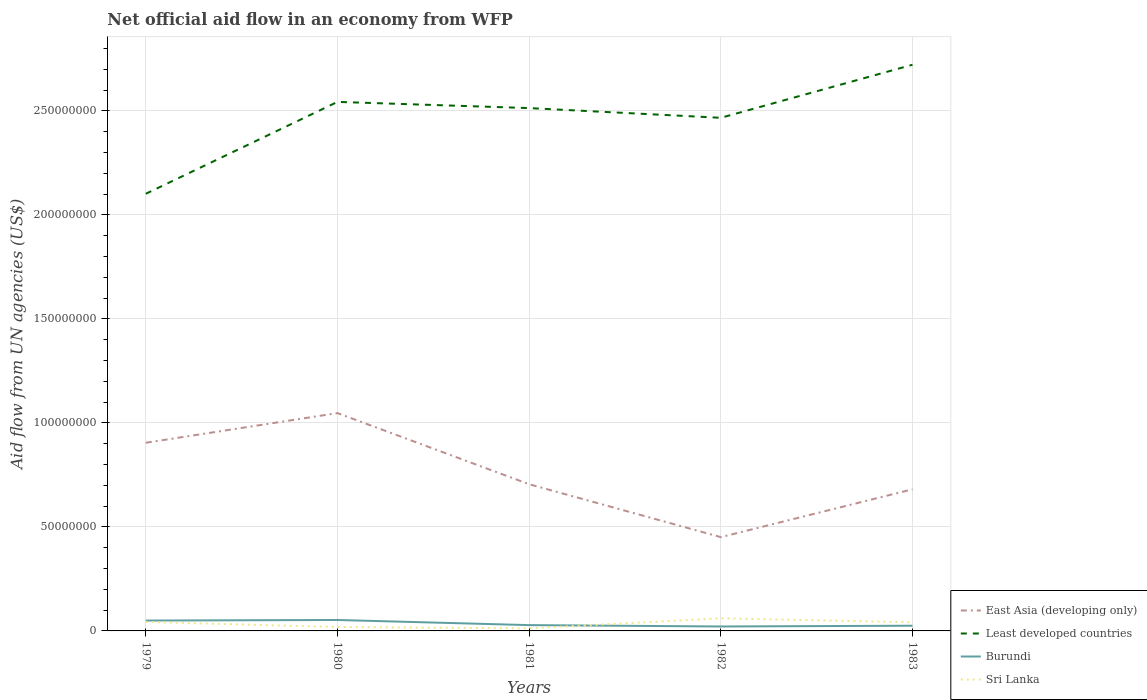How many different coloured lines are there?
Make the answer very short. 4. Is the number of lines equal to the number of legend labels?
Offer a very short reply. Yes. Across all years, what is the maximum net official aid flow in East Asia (developing only)?
Ensure brevity in your answer.  4.51e+07. In which year was the net official aid flow in Burundi maximum?
Give a very brief answer. 1982. What is the total net official aid flow in Sri Lanka in the graph?
Provide a short and direct response. -4.19e+06. What is the difference between the highest and the second highest net official aid flow in Burundi?
Your answer should be compact. 3.13e+06. Is the net official aid flow in Sri Lanka strictly greater than the net official aid flow in East Asia (developing only) over the years?
Offer a terse response. Yes. What is the difference between two consecutive major ticks on the Y-axis?
Your answer should be very brief. 5.00e+07. Are the values on the major ticks of Y-axis written in scientific E-notation?
Provide a short and direct response. No. Does the graph contain any zero values?
Make the answer very short. No. Does the graph contain grids?
Make the answer very short. Yes. How many legend labels are there?
Ensure brevity in your answer.  4. How are the legend labels stacked?
Keep it short and to the point. Vertical. What is the title of the graph?
Ensure brevity in your answer.  Net official aid flow in an economy from WFP. Does "Sub-Saharan Africa (developing only)" appear as one of the legend labels in the graph?
Your answer should be compact. No. What is the label or title of the X-axis?
Your answer should be very brief. Years. What is the label or title of the Y-axis?
Offer a very short reply. Aid flow from UN agencies (US$). What is the Aid flow from UN agencies (US$) of East Asia (developing only) in 1979?
Offer a very short reply. 9.04e+07. What is the Aid flow from UN agencies (US$) in Least developed countries in 1979?
Offer a very short reply. 2.10e+08. What is the Aid flow from UN agencies (US$) in Burundi in 1979?
Your answer should be compact. 4.99e+06. What is the Aid flow from UN agencies (US$) in Sri Lanka in 1979?
Ensure brevity in your answer.  4.31e+06. What is the Aid flow from UN agencies (US$) of East Asia (developing only) in 1980?
Make the answer very short. 1.05e+08. What is the Aid flow from UN agencies (US$) of Least developed countries in 1980?
Make the answer very short. 2.54e+08. What is the Aid flow from UN agencies (US$) of Burundi in 1980?
Your answer should be very brief. 5.26e+06. What is the Aid flow from UN agencies (US$) in Sri Lanka in 1980?
Provide a succinct answer. 1.89e+06. What is the Aid flow from UN agencies (US$) of East Asia (developing only) in 1981?
Offer a terse response. 7.05e+07. What is the Aid flow from UN agencies (US$) of Least developed countries in 1981?
Your response must be concise. 2.51e+08. What is the Aid flow from UN agencies (US$) of Burundi in 1981?
Your answer should be very brief. 2.79e+06. What is the Aid flow from UN agencies (US$) of Sri Lanka in 1981?
Give a very brief answer. 1.23e+06. What is the Aid flow from UN agencies (US$) of East Asia (developing only) in 1982?
Ensure brevity in your answer.  4.51e+07. What is the Aid flow from UN agencies (US$) in Least developed countries in 1982?
Give a very brief answer. 2.47e+08. What is the Aid flow from UN agencies (US$) in Burundi in 1982?
Provide a succinct answer. 2.13e+06. What is the Aid flow from UN agencies (US$) of Sri Lanka in 1982?
Offer a terse response. 6.08e+06. What is the Aid flow from UN agencies (US$) in East Asia (developing only) in 1983?
Your response must be concise. 6.81e+07. What is the Aid flow from UN agencies (US$) of Least developed countries in 1983?
Offer a very short reply. 2.72e+08. What is the Aid flow from UN agencies (US$) in Burundi in 1983?
Keep it short and to the point. 2.50e+06. What is the Aid flow from UN agencies (US$) of Sri Lanka in 1983?
Keep it short and to the point. 4.14e+06. Across all years, what is the maximum Aid flow from UN agencies (US$) of East Asia (developing only)?
Ensure brevity in your answer.  1.05e+08. Across all years, what is the maximum Aid flow from UN agencies (US$) in Least developed countries?
Ensure brevity in your answer.  2.72e+08. Across all years, what is the maximum Aid flow from UN agencies (US$) of Burundi?
Offer a terse response. 5.26e+06. Across all years, what is the maximum Aid flow from UN agencies (US$) in Sri Lanka?
Offer a terse response. 6.08e+06. Across all years, what is the minimum Aid flow from UN agencies (US$) of East Asia (developing only)?
Ensure brevity in your answer.  4.51e+07. Across all years, what is the minimum Aid flow from UN agencies (US$) of Least developed countries?
Your response must be concise. 2.10e+08. Across all years, what is the minimum Aid flow from UN agencies (US$) in Burundi?
Give a very brief answer. 2.13e+06. Across all years, what is the minimum Aid flow from UN agencies (US$) in Sri Lanka?
Provide a short and direct response. 1.23e+06. What is the total Aid flow from UN agencies (US$) in East Asia (developing only) in the graph?
Give a very brief answer. 3.79e+08. What is the total Aid flow from UN agencies (US$) of Least developed countries in the graph?
Provide a succinct answer. 1.23e+09. What is the total Aid flow from UN agencies (US$) in Burundi in the graph?
Give a very brief answer. 1.77e+07. What is the total Aid flow from UN agencies (US$) in Sri Lanka in the graph?
Your answer should be compact. 1.76e+07. What is the difference between the Aid flow from UN agencies (US$) of East Asia (developing only) in 1979 and that in 1980?
Give a very brief answer. -1.42e+07. What is the difference between the Aid flow from UN agencies (US$) of Least developed countries in 1979 and that in 1980?
Give a very brief answer. -4.42e+07. What is the difference between the Aid flow from UN agencies (US$) of Sri Lanka in 1979 and that in 1980?
Your answer should be very brief. 2.42e+06. What is the difference between the Aid flow from UN agencies (US$) in East Asia (developing only) in 1979 and that in 1981?
Your answer should be compact. 1.99e+07. What is the difference between the Aid flow from UN agencies (US$) of Least developed countries in 1979 and that in 1981?
Give a very brief answer. -4.12e+07. What is the difference between the Aid flow from UN agencies (US$) in Burundi in 1979 and that in 1981?
Provide a succinct answer. 2.20e+06. What is the difference between the Aid flow from UN agencies (US$) in Sri Lanka in 1979 and that in 1981?
Provide a succinct answer. 3.08e+06. What is the difference between the Aid flow from UN agencies (US$) of East Asia (developing only) in 1979 and that in 1982?
Keep it short and to the point. 4.54e+07. What is the difference between the Aid flow from UN agencies (US$) of Least developed countries in 1979 and that in 1982?
Make the answer very short. -3.65e+07. What is the difference between the Aid flow from UN agencies (US$) in Burundi in 1979 and that in 1982?
Your answer should be compact. 2.86e+06. What is the difference between the Aid flow from UN agencies (US$) in Sri Lanka in 1979 and that in 1982?
Offer a terse response. -1.77e+06. What is the difference between the Aid flow from UN agencies (US$) of East Asia (developing only) in 1979 and that in 1983?
Your answer should be compact. 2.24e+07. What is the difference between the Aid flow from UN agencies (US$) in Least developed countries in 1979 and that in 1983?
Keep it short and to the point. -6.20e+07. What is the difference between the Aid flow from UN agencies (US$) in Burundi in 1979 and that in 1983?
Your answer should be very brief. 2.49e+06. What is the difference between the Aid flow from UN agencies (US$) of East Asia (developing only) in 1980 and that in 1981?
Keep it short and to the point. 3.42e+07. What is the difference between the Aid flow from UN agencies (US$) in Least developed countries in 1980 and that in 1981?
Your answer should be compact. 2.98e+06. What is the difference between the Aid flow from UN agencies (US$) in Burundi in 1980 and that in 1981?
Provide a short and direct response. 2.47e+06. What is the difference between the Aid flow from UN agencies (US$) of East Asia (developing only) in 1980 and that in 1982?
Give a very brief answer. 5.96e+07. What is the difference between the Aid flow from UN agencies (US$) of Least developed countries in 1980 and that in 1982?
Give a very brief answer. 7.65e+06. What is the difference between the Aid flow from UN agencies (US$) in Burundi in 1980 and that in 1982?
Keep it short and to the point. 3.13e+06. What is the difference between the Aid flow from UN agencies (US$) of Sri Lanka in 1980 and that in 1982?
Offer a terse response. -4.19e+06. What is the difference between the Aid flow from UN agencies (US$) in East Asia (developing only) in 1980 and that in 1983?
Your answer should be compact. 3.66e+07. What is the difference between the Aid flow from UN agencies (US$) in Least developed countries in 1980 and that in 1983?
Make the answer very short. -1.78e+07. What is the difference between the Aid flow from UN agencies (US$) in Burundi in 1980 and that in 1983?
Ensure brevity in your answer.  2.76e+06. What is the difference between the Aid flow from UN agencies (US$) of Sri Lanka in 1980 and that in 1983?
Make the answer very short. -2.25e+06. What is the difference between the Aid flow from UN agencies (US$) in East Asia (developing only) in 1981 and that in 1982?
Ensure brevity in your answer.  2.54e+07. What is the difference between the Aid flow from UN agencies (US$) of Least developed countries in 1981 and that in 1982?
Keep it short and to the point. 4.67e+06. What is the difference between the Aid flow from UN agencies (US$) of Burundi in 1981 and that in 1982?
Ensure brevity in your answer.  6.60e+05. What is the difference between the Aid flow from UN agencies (US$) of Sri Lanka in 1981 and that in 1982?
Your answer should be very brief. -4.85e+06. What is the difference between the Aid flow from UN agencies (US$) in East Asia (developing only) in 1981 and that in 1983?
Keep it short and to the point. 2.44e+06. What is the difference between the Aid flow from UN agencies (US$) of Least developed countries in 1981 and that in 1983?
Your response must be concise. -2.08e+07. What is the difference between the Aid flow from UN agencies (US$) of Sri Lanka in 1981 and that in 1983?
Provide a succinct answer. -2.91e+06. What is the difference between the Aid flow from UN agencies (US$) of East Asia (developing only) in 1982 and that in 1983?
Your answer should be compact. -2.30e+07. What is the difference between the Aid flow from UN agencies (US$) in Least developed countries in 1982 and that in 1983?
Your answer should be very brief. -2.55e+07. What is the difference between the Aid flow from UN agencies (US$) in Burundi in 1982 and that in 1983?
Your answer should be very brief. -3.70e+05. What is the difference between the Aid flow from UN agencies (US$) of Sri Lanka in 1982 and that in 1983?
Offer a terse response. 1.94e+06. What is the difference between the Aid flow from UN agencies (US$) of East Asia (developing only) in 1979 and the Aid flow from UN agencies (US$) of Least developed countries in 1980?
Keep it short and to the point. -1.64e+08. What is the difference between the Aid flow from UN agencies (US$) of East Asia (developing only) in 1979 and the Aid flow from UN agencies (US$) of Burundi in 1980?
Your answer should be compact. 8.52e+07. What is the difference between the Aid flow from UN agencies (US$) of East Asia (developing only) in 1979 and the Aid flow from UN agencies (US$) of Sri Lanka in 1980?
Offer a terse response. 8.86e+07. What is the difference between the Aid flow from UN agencies (US$) of Least developed countries in 1979 and the Aid flow from UN agencies (US$) of Burundi in 1980?
Provide a short and direct response. 2.05e+08. What is the difference between the Aid flow from UN agencies (US$) in Least developed countries in 1979 and the Aid flow from UN agencies (US$) in Sri Lanka in 1980?
Offer a very short reply. 2.08e+08. What is the difference between the Aid flow from UN agencies (US$) of Burundi in 1979 and the Aid flow from UN agencies (US$) of Sri Lanka in 1980?
Your answer should be very brief. 3.10e+06. What is the difference between the Aid flow from UN agencies (US$) of East Asia (developing only) in 1979 and the Aid flow from UN agencies (US$) of Least developed countries in 1981?
Your response must be concise. -1.61e+08. What is the difference between the Aid flow from UN agencies (US$) in East Asia (developing only) in 1979 and the Aid flow from UN agencies (US$) in Burundi in 1981?
Make the answer very short. 8.77e+07. What is the difference between the Aid flow from UN agencies (US$) of East Asia (developing only) in 1979 and the Aid flow from UN agencies (US$) of Sri Lanka in 1981?
Offer a terse response. 8.92e+07. What is the difference between the Aid flow from UN agencies (US$) in Least developed countries in 1979 and the Aid flow from UN agencies (US$) in Burundi in 1981?
Give a very brief answer. 2.07e+08. What is the difference between the Aid flow from UN agencies (US$) of Least developed countries in 1979 and the Aid flow from UN agencies (US$) of Sri Lanka in 1981?
Your answer should be very brief. 2.09e+08. What is the difference between the Aid flow from UN agencies (US$) in Burundi in 1979 and the Aid flow from UN agencies (US$) in Sri Lanka in 1981?
Your response must be concise. 3.76e+06. What is the difference between the Aid flow from UN agencies (US$) of East Asia (developing only) in 1979 and the Aid flow from UN agencies (US$) of Least developed countries in 1982?
Your answer should be very brief. -1.56e+08. What is the difference between the Aid flow from UN agencies (US$) of East Asia (developing only) in 1979 and the Aid flow from UN agencies (US$) of Burundi in 1982?
Offer a terse response. 8.83e+07. What is the difference between the Aid flow from UN agencies (US$) of East Asia (developing only) in 1979 and the Aid flow from UN agencies (US$) of Sri Lanka in 1982?
Offer a terse response. 8.44e+07. What is the difference between the Aid flow from UN agencies (US$) of Least developed countries in 1979 and the Aid flow from UN agencies (US$) of Burundi in 1982?
Make the answer very short. 2.08e+08. What is the difference between the Aid flow from UN agencies (US$) of Least developed countries in 1979 and the Aid flow from UN agencies (US$) of Sri Lanka in 1982?
Give a very brief answer. 2.04e+08. What is the difference between the Aid flow from UN agencies (US$) in Burundi in 1979 and the Aid flow from UN agencies (US$) in Sri Lanka in 1982?
Make the answer very short. -1.09e+06. What is the difference between the Aid flow from UN agencies (US$) of East Asia (developing only) in 1979 and the Aid flow from UN agencies (US$) of Least developed countries in 1983?
Your answer should be compact. -1.82e+08. What is the difference between the Aid flow from UN agencies (US$) of East Asia (developing only) in 1979 and the Aid flow from UN agencies (US$) of Burundi in 1983?
Your answer should be very brief. 8.80e+07. What is the difference between the Aid flow from UN agencies (US$) in East Asia (developing only) in 1979 and the Aid flow from UN agencies (US$) in Sri Lanka in 1983?
Offer a very short reply. 8.63e+07. What is the difference between the Aid flow from UN agencies (US$) of Least developed countries in 1979 and the Aid flow from UN agencies (US$) of Burundi in 1983?
Your response must be concise. 2.08e+08. What is the difference between the Aid flow from UN agencies (US$) of Least developed countries in 1979 and the Aid flow from UN agencies (US$) of Sri Lanka in 1983?
Offer a terse response. 2.06e+08. What is the difference between the Aid flow from UN agencies (US$) in Burundi in 1979 and the Aid flow from UN agencies (US$) in Sri Lanka in 1983?
Ensure brevity in your answer.  8.50e+05. What is the difference between the Aid flow from UN agencies (US$) in East Asia (developing only) in 1980 and the Aid flow from UN agencies (US$) in Least developed countries in 1981?
Your response must be concise. -1.47e+08. What is the difference between the Aid flow from UN agencies (US$) of East Asia (developing only) in 1980 and the Aid flow from UN agencies (US$) of Burundi in 1981?
Ensure brevity in your answer.  1.02e+08. What is the difference between the Aid flow from UN agencies (US$) in East Asia (developing only) in 1980 and the Aid flow from UN agencies (US$) in Sri Lanka in 1981?
Keep it short and to the point. 1.03e+08. What is the difference between the Aid flow from UN agencies (US$) of Least developed countries in 1980 and the Aid flow from UN agencies (US$) of Burundi in 1981?
Provide a succinct answer. 2.52e+08. What is the difference between the Aid flow from UN agencies (US$) of Least developed countries in 1980 and the Aid flow from UN agencies (US$) of Sri Lanka in 1981?
Provide a succinct answer. 2.53e+08. What is the difference between the Aid flow from UN agencies (US$) in Burundi in 1980 and the Aid flow from UN agencies (US$) in Sri Lanka in 1981?
Your response must be concise. 4.03e+06. What is the difference between the Aid flow from UN agencies (US$) of East Asia (developing only) in 1980 and the Aid flow from UN agencies (US$) of Least developed countries in 1982?
Your answer should be compact. -1.42e+08. What is the difference between the Aid flow from UN agencies (US$) of East Asia (developing only) in 1980 and the Aid flow from UN agencies (US$) of Burundi in 1982?
Your response must be concise. 1.03e+08. What is the difference between the Aid flow from UN agencies (US$) of East Asia (developing only) in 1980 and the Aid flow from UN agencies (US$) of Sri Lanka in 1982?
Offer a terse response. 9.86e+07. What is the difference between the Aid flow from UN agencies (US$) in Least developed countries in 1980 and the Aid flow from UN agencies (US$) in Burundi in 1982?
Offer a terse response. 2.52e+08. What is the difference between the Aid flow from UN agencies (US$) of Least developed countries in 1980 and the Aid flow from UN agencies (US$) of Sri Lanka in 1982?
Give a very brief answer. 2.48e+08. What is the difference between the Aid flow from UN agencies (US$) in Burundi in 1980 and the Aid flow from UN agencies (US$) in Sri Lanka in 1982?
Make the answer very short. -8.20e+05. What is the difference between the Aid flow from UN agencies (US$) of East Asia (developing only) in 1980 and the Aid flow from UN agencies (US$) of Least developed countries in 1983?
Provide a short and direct response. -1.67e+08. What is the difference between the Aid flow from UN agencies (US$) of East Asia (developing only) in 1980 and the Aid flow from UN agencies (US$) of Burundi in 1983?
Provide a short and direct response. 1.02e+08. What is the difference between the Aid flow from UN agencies (US$) of East Asia (developing only) in 1980 and the Aid flow from UN agencies (US$) of Sri Lanka in 1983?
Provide a short and direct response. 1.01e+08. What is the difference between the Aid flow from UN agencies (US$) of Least developed countries in 1980 and the Aid flow from UN agencies (US$) of Burundi in 1983?
Offer a very short reply. 2.52e+08. What is the difference between the Aid flow from UN agencies (US$) of Least developed countries in 1980 and the Aid flow from UN agencies (US$) of Sri Lanka in 1983?
Your response must be concise. 2.50e+08. What is the difference between the Aid flow from UN agencies (US$) of Burundi in 1980 and the Aid flow from UN agencies (US$) of Sri Lanka in 1983?
Offer a very short reply. 1.12e+06. What is the difference between the Aid flow from UN agencies (US$) in East Asia (developing only) in 1981 and the Aid flow from UN agencies (US$) in Least developed countries in 1982?
Your answer should be very brief. -1.76e+08. What is the difference between the Aid flow from UN agencies (US$) in East Asia (developing only) in 1981 and the Aid flow from UN agencies (US$) in Burundi in 1982?
Offer a very short reply. 6.84e+07. What is the difference between the Aid flow from UN agencies (US$) in East Asia (developing only) in 1981 and the Aid flow from UN agencies (US$) in Sri Lanka in 1982?
Keep it short and to the point. 6.44e+07. What is the difference between the Aid flow from UN agencies (US$) in Least developed countries in 1981 and the Aid flow from UN agencies (US$) in Burundi in 1982?
Offer a terse response. 2.49e+08. What is the difference between the Aid flow from UN agencies (US$) in Least developed countries in 1981 and the Aid flow from UN agencies (US$) in Sri Lanka in 1982?
Your answer should be very brief. 2.45e+08. What is the difference between the Aid flow from UN agencies (US$) in Burundi in 1981 and the Aid flow from UN agencies (US$) in Sri Lanka in 1982?
Offer a terse response. -3.29e+06. What is the difference between the Aid flow from UN agencies (US$) of East Asia (developing only) in 1981 and the Aid flow from UN agencies (US$) of Least developed countries in 1983?
Make the answer very short. -2.02e+08. What is the difference between the Aid flow from UN agencies (US$) in East Asia (developing only) in 1981 and the Aid flow from UN agencies (US$) in Burundi in 1983?
Your answer should be very brief. 6.80e+07. What is the difference between the Aid flow from UN agencies (US$) of East Asia (developing only) in 1981 and the Aid flow from UN agencies (US$) of Sri Lanka in 1983?
Provide a succinct answer. 6.64e+07. What is the difference between the Aid flow from UN agencies (US$) in Least developed countries in 1981 and the Aid flow from UN agencies (US$) in Burundi in 1983?
Give a very brief answer. 2.49e+08. What is the difference between the Aid flow from UN agencies (US$) of Least developed countries in 1981 and the Aid flow from UN agencies (US$) of Sri Lanka in 1983?
Your answer should be very brief. 2.47e+08. What is the difference between the Aid flow from UN agencies (US$) of Burundi in 1981 and the Aid flow from UN agencies (US$) of Sri Lanka in 1983?
Offer a terse response. -1.35e+06. What is the difference between the Aid flow from UN agencies (US$) of East Asia (developing only) in 1982 and the Aid flow from UN agencies (US$) of Least developed countries in 1983?
Provide a short and direct response. -2.27e+08. What is the difference between the Aid flow from UN agencies (US$) in East Asia (developing only) in 1982 and the Aid flow from UN agencies (US$) in Burundi in 1983?
Provide a short and direct response. 4.26e+07. What is the difference between the Aid flow from UN agencies (US$) in East Asia (developing only) in 1982 and the Aid flow from UN agencies (US$) in Sri Lanka in 1983?
Offer a very short reply. 4.09e+07. What is the difference between the Aid flow from UN agencies (US$) in Least developed countries in 1982 and the Aid flow from UN agencies (US$) in Burundi in 1983?
Keep it short and to the point. 2.44e+08. What is the difference between the Aid flow from UN agencies (US$) of Least developed countries in 1982 and the Aid flow from UN agencies (US$) of Sri Lanka in 1983?
Your answer should be very brief. 2.42e+08. What is the difference between the Aid flow from UN agencies (US$) in Burundi in 1982 and the Aid flow from UN agencies (US$) in Sri Lanka in 1983?
Your answer should be compact. -2.01e+06. What is the average Aid flow from UN agencies (US$) in East Asia (developing only) per year?
Provide a succinct answer. 7.58e+07. What is the average Aid flow from UN agencies (US$) of Least developed countries per year?
Keep it short and to the point. 2.47e+08. What is the average Aid flow from UN agencies (US$) in Burundi per year?
Offer a very short reply. 3.53e+06. What is the average Aid flow from UN agencies (US$) in Sri Lanka per year?
Give a very brief answer. 3.53e+06. In the year 1979, what is the difference between the Aid flow from UN agencies (US$) of East Asia (developing only) and Aid flow from UN agencies (US$) of Least developed countries?
Your response must be concise. -1.20e+08. In the year 1979, what is the difference between the Aid flow from UN agencies (US$) of East Asia (developing only) and Aid flow from UN agencies (US$) of Burundi?
Make the answer very short. 8.55e+07. In the year 1979, what is the difference between the Aid flow from UN agencies (US$) in East Asia (developing only) and Aid flow from UN agencies (US$) in Sri Lanka?
Your response must be concise. 8.61e+07. In the year 1979, what is the difference between the Aid flow from UN agencies (US$) of Least developed countries and Aid flow from UN agencies (US$) of Burundi?
Ensure brevity in your answer.  2.05e+08. In the year 1979, what is the difference between the Aid flow from UN agencies (US$) of Least developed countries and Aid flow from UN agencies (US$) of Sri Lanka?
Ensure brevity in your answer.  2.06e+08. In the year 1979, what is the difference between the Aid flow from UN agencies (US$) of Burundi and Aid flow from UN agencies (US$) of Sri Lanka?
Offer a terse response. 6.80e+05. In the year 1980, what is the difference between the Aid flow from UN agencies (US$) in East Asia (developing only) and Aid flow from UN agencies (US$) in Least developed countries?
Make the answer very short. -1.50e+08. In the year 1980, what is the difference between the Aid flow from UN agencies (US$) in East Asia (developing only) and Aid flow from UN agencies (US$) in Burundi?
Give a very brief answer. 9.94e+07. In the year 1980, what is the difference between the Aid flow from UN agencies (US$) in East Asia (developing only) and Aid flow from UN agencies (US$) in Sri Lanka?
Keep it short and to the point. 1.03e+08. In the year 1980, what is the difference between the Aid flow from UN agencies (US$) of Least developed countries and Aid flow from UN agencies (US$) of Burundi?
Make the answer very short. 2.49e+08. In the year 1980, what is the difference between the Aid flow from UN agencies (US$) of Least developed countries and Aid flow from UN agencies (US$) of Sri Lanka?
Make the answer very short. 2.52e+08. In the year 1980, what is the difference between the Aid flow from UN agencies (US$) in Burundi and Aid flow from UN agencies (US$) in Sri Lanka?
Your answer should be very brief. 3.37e+06. In the year 1981, what is the difference between the Aid flow from UN agencies (US$) in East Asia (developing only) and Aid flow from UN agencies (US$) in Least developed countries?
Your answer should be compact. -1.81e+08. In the year 1981, what is the difference between the Aid flow from UN agencies (US$) of East Asia (developing only) and Aid flow from UN agencies (US$) of Burundi?
Your response must be concise. 6.77e+07. In the year 1981, what is the difference between the Aid flow from UN agencies (US$) of East Asia (developing only) and Aid flow from UN agencies (US$) of Sri Lanka?
Provide a short and direct response. 6.93e+07. In the year 1981, what is the difference between the Aid flow from UN agencies (US$) in Least developed countries and Aid flow from UN agencies (US$) in Burundi?
Your response must be concise. 2.49e+08. In the year 1981, what is the difference between the Aid flow from UN agencies (US$) in Least developed countries and Aid flow from UN agencies (US$) in Sri Lanka?
Provide a short and direct response. 2.50e+08. In the year 1981, what is the difference between the Aid flow from UN agencies (US$) of Burundi and Aid flow from UN agencies (US$) of Sri Lanka?
Give a very brief answer. 1.56e+06. In the year 1982, what is the difference between the Aid flow from UN agencies (US$) of East Asia (developing only) and Aid flow from UN agencies (US$) of Least developed countries?
Your response must be concise. -2.02e+08. In the year 1982, what is the difference between the Aid flow from UN agencies (US$) of East Asia (developing only) and Aid flow from UN agencies (US$) of Burundi?
Provide a short and direct response. 4.30e+07. In the year 1982, what is the difference between the Aid flow from UN agencies (US$) of East Asia (developing only) and Aid flow from UN agencies (US$) of Sri Lanka?
Give a very brief answer. 3.90e+07. In the year 1982, what is the difference between the Aid flow from UN agencies (US$) in Least developed countries and Aid flow from UN agencies (US$) in Burundi?
Make the answer very short. 2.45e+08. In the year 1982, what is the difference between the Aid flow from UN agencies (US$) in Least developed countries and Aid flow from UN agencies (US$) in Sri Lanka?
Provide a succinct answer. 2.41e+08. In the year 1982, what is the difference between the Aid flow from UN agencies (US$) in Burundi and Aid flow from UN agencies (US$) in Sri Lanka?
Your answer should be very brief. -3.95e+06. In the year 1983, what is the difference between the Aid flow from UN agencies (US$) in East Asia (developing only) and Aid flow from UN agencies (US$) in Least developed countries?
Your answer should be very brief. -2.04e+08. In the year 1983, what is the difference between the Aid flow from UN agencies (US$) of East Asia (developing only) and Aid flow from UN agencies (US$) of Burundi?
Ensure brevity in your answer.  6.56e+07. In the year 1983, what is the difference between the Aid flow from UN agencies (US$) of East Asia (developing only) and Aid flow from UN agencies (US$) of Sri Lanka?
Your answer should be very brief. 6.39e+07. In the year 1983, what is the difference between the Aid flow from UN agencies (US$) of Least developed countries and Aid flow from UN agencies (US$) of Burundi?
Give a very brief answer. 2.70e+08. In the year 1983, what is the difference between the Aid flow from UN agencies (US$) in Least developed countries and Aid flow from UN agencies (US$) in Sri Lanka?
Provide a succinct answer. 2.68e+08. In the year 1983, what is the difference between the Aid flow from UN agencies (US$) in Burundi and Aid flow from UN agencies (US$) in Sri Lanka?
Your answer should be very brief. -1.64e+06. What is the ratio of the Aid flow from UN agencies (US$) in East Asia (developing only) in 1979 to that in 1980?
Your answer should be compact. 0.86. What is the ratio of the Aid flow from UN agencies (US$) of Least developed countries in 1979 to that in 1980?
Ensure brevity in your answer.  0.83. What is the ratio of the Aid flow from UN agencies (US$) of Burundi in 1979 to that in 1980?
Offer a terse response. 0.95. What is the ratio of the Aid flow from UN agencies (US$) in Sri Lanka in 1979 to that in 1980?
Make the answer very short. 2.28. What is the ratio of the Aid flow from UN agencies (US$) in East Asia (developing only) in 1979 to that in 1981?
Provide a succinct answer. 1.28. What is the ratio of the Aid flow from UN agencies (US$) in Least developed countries in 1979 to that in 1981?
Ensure brevity in your answer.  0.84. What is the ratio of the Aid flow from UN agencies (US$) in Burundi in 1979 to that in 1981?
Provide a succinct answer. 1.79. What is the ratio of the Aid flow from UN agencies (US$) of Sri Lanka in 1979 to that in 1981?
Make the answer very short. 3.5. What is the ratio of the Aid flow from UN agencies (US$) in East Asia (developing only) in 1979 to that in 1982?
Offer a very short reply. 2.01. What is the ratio of the Aid flow from UN agencies (US$) of Least developed countries in 1979 to that in 1982?
Offer a very short reply. 0.85. What is the ratio of the Aid flow from UN agencies (US$) of Burundi in 1979 to that in 1982?
Provide a succinct answer. 2.34. What is the ratio of the Aid flow from UN agencies (US$) in Sri Lanka in 1979 to that in 1982?
Your answer should be very brief. 0.71. What is the ratio of the Aid flow from UN agencies (US$) in East Asia (developing only) in 1979 to that in 1983?
Provide a succinct answer. 1.33. What is the ratio of the Aid flow from UN agencies (US$) of Least developed countries in 1979 to that in 1983?
Offer a terse response. 0.77. What is the ratio of the Aid flow from UN agencies (US$) in Burundi in 1979 to that in 1983?
Your response must be concise. 2. What is the ratio of the Aid flow from UN agencies (US$) of Sri Lanka in 1979 to that in 1983?
Keep it short and to the point. 1.04. What is the ratio of the Aid flow from UN agencies (US$) of East Asia (developing only) in 1980 to that in 1981?
Your response must be concise. 1.48. What is the ratio of the Aid flow from UN agencies (US$) in Least developed countries in 1980 to that in 1981?
Make the answer very short. 1.01. What is the ratio of the Aid flow from UN agencies (US$) in Burundi in 1980 to that in 1981?
Your response must be concise. 1.89. What is the ratio of the Aid flow from UN agencies (US$) in Sri Lanka in 1980 to that in 1981?
Offer a terse response. 1.54. What is the ratio of the Aid flow from UN agencies (US$) of East Asia (developing only) in 1980 to that in 1982?
Provide a succinct answer. 2.32. What is the ratio of the Aid flow from UN agencies (US$) of Least developed countries in 1980 to that in 1982?
Provide a succinct answer. 1.03. What is the ratio of the Aid flow from UN agencies (US$) of Burundi in 1980 to that in 1982?
Your response must be concise. 2.47. What is the ratio of the Aid flow from UN agencies (US$) in Sri Lanka in 1980 to that in 1982?
Make the answer very short. 0.31. What is the ratio of the Aid flow from UN agencies (US$) in East Asia (developing only) in 1980 to that in 1983?
Provide a short and direct response. 1.54. What is the ratio of the Aid flow from UN agencies (US$) in Least developed countries in 1980 to that in 1983?
Provide a short and direct response. 0.93. What is the ratio of the Aid flow from UN agencies (US$) of Burundi in 1980 to that in 1983?
Make the answer very short. 2.1. What is the ratio of the Aid flow from UN agencies (US$) of Sri Lanka in 1980 to that in 1983?
Make the answer very short. 0.46. What is the ratio of the Aid flow from UN agencies (US$) in East Asia (developing only) in 1981 to that in 1982?
Keep it short and to the point. 1.56. What is the ratio of the Aid flow from UN agencies (US$) of Least developed countries in 1981 to that in 1982?
Make the answer very short. 1.02. What is the ratio of the Aid flow from UN agencies (US$) in Burundi in 1981 to that in 1982?
Provide a short and direct response. 1.31. What is the ratio of the Aid flow from UN agencies (US$) of Sri Lanka in 1981 to that in 1982?
Keep it short and to the point. 0.2. What is the ratio of the Aid flow from UN agencies (US$) in East Asia (developing only) in 1981 to that in 1983?
Provide a short and direct response. 1.04. What is the ratio of the Aid flow from UN agencies (US$) of Least developed countries in 1981 to that in 1983?
Keep it short and to the point. 0.92. What is the ratio of the Aid flow from UN agencies (US$) of Burundi in 1981 to that in 1983?
Keep it short and to the point. 1.12. What is the ratio of the Aid flow from UN agencies (US$) in Sri Lanka in 1981 to that in 1983?
Offer a terse response. 0.3. What is the ratio of the Aid flow from UN agencies (US$) in East Asia (developing only) in 1982 to that in 1983?
Provide a succinct answer. 0.66. What is the ratio of the Aid flow from UN agencies (US$) in Least developed countries in 1982 to that in 1983?
Make the answer very short. 0.91. What is the ratio of the Aid flow from UN agencies (US$) in Burundi in 1982 to that in 1983?
Give a very brief answer. 0.85. What is the ratio of the Aid flow from UN agencies (US$) of Sri Lanka in 1982 to that in 1983?
Your answer should be compact. 1.47. What is the difference between the highest and the second highest Aid flow from UN agencies (US$) of East Asia (developing only)?
Offer a very short reply. 1.42e+07. What is the difference between the highest and the second highest Aid flow from UN agencies (US$) in Least developed countries?
Give a very brief answer. 1.78e+07. What is the difference between the highest and the second highest Aid flow from UN agencies (US$) of Burundi?
Your answer should be very brief. 2.70e+05. What is the difference between the highest and the second highest Aid flow from UN agencies (US$) of Sri Lanka?
Provide a succinct answer. 1.77e+06. What is the difference between the highest and the lowest Aid flow from UN agencies (US$) of East Asia (developing only)?
Keep it short and to the point. 5.96e+07. What is the difference between the highest and the lowest Aid flow from UN agencies (US$) of Least developed countries?
Your answer should be compact. 6.20e+07. What is the difference between the highest and the lowest Aid flow from UN agencies (US$) in Burundi?
Give a very brief answer. 3.13e+06. What is the difference between the highest and the lowest Aid flow from UN agencies (US$) in Sri Lanka?
Provide a succinct answer. 4.85e+06. 